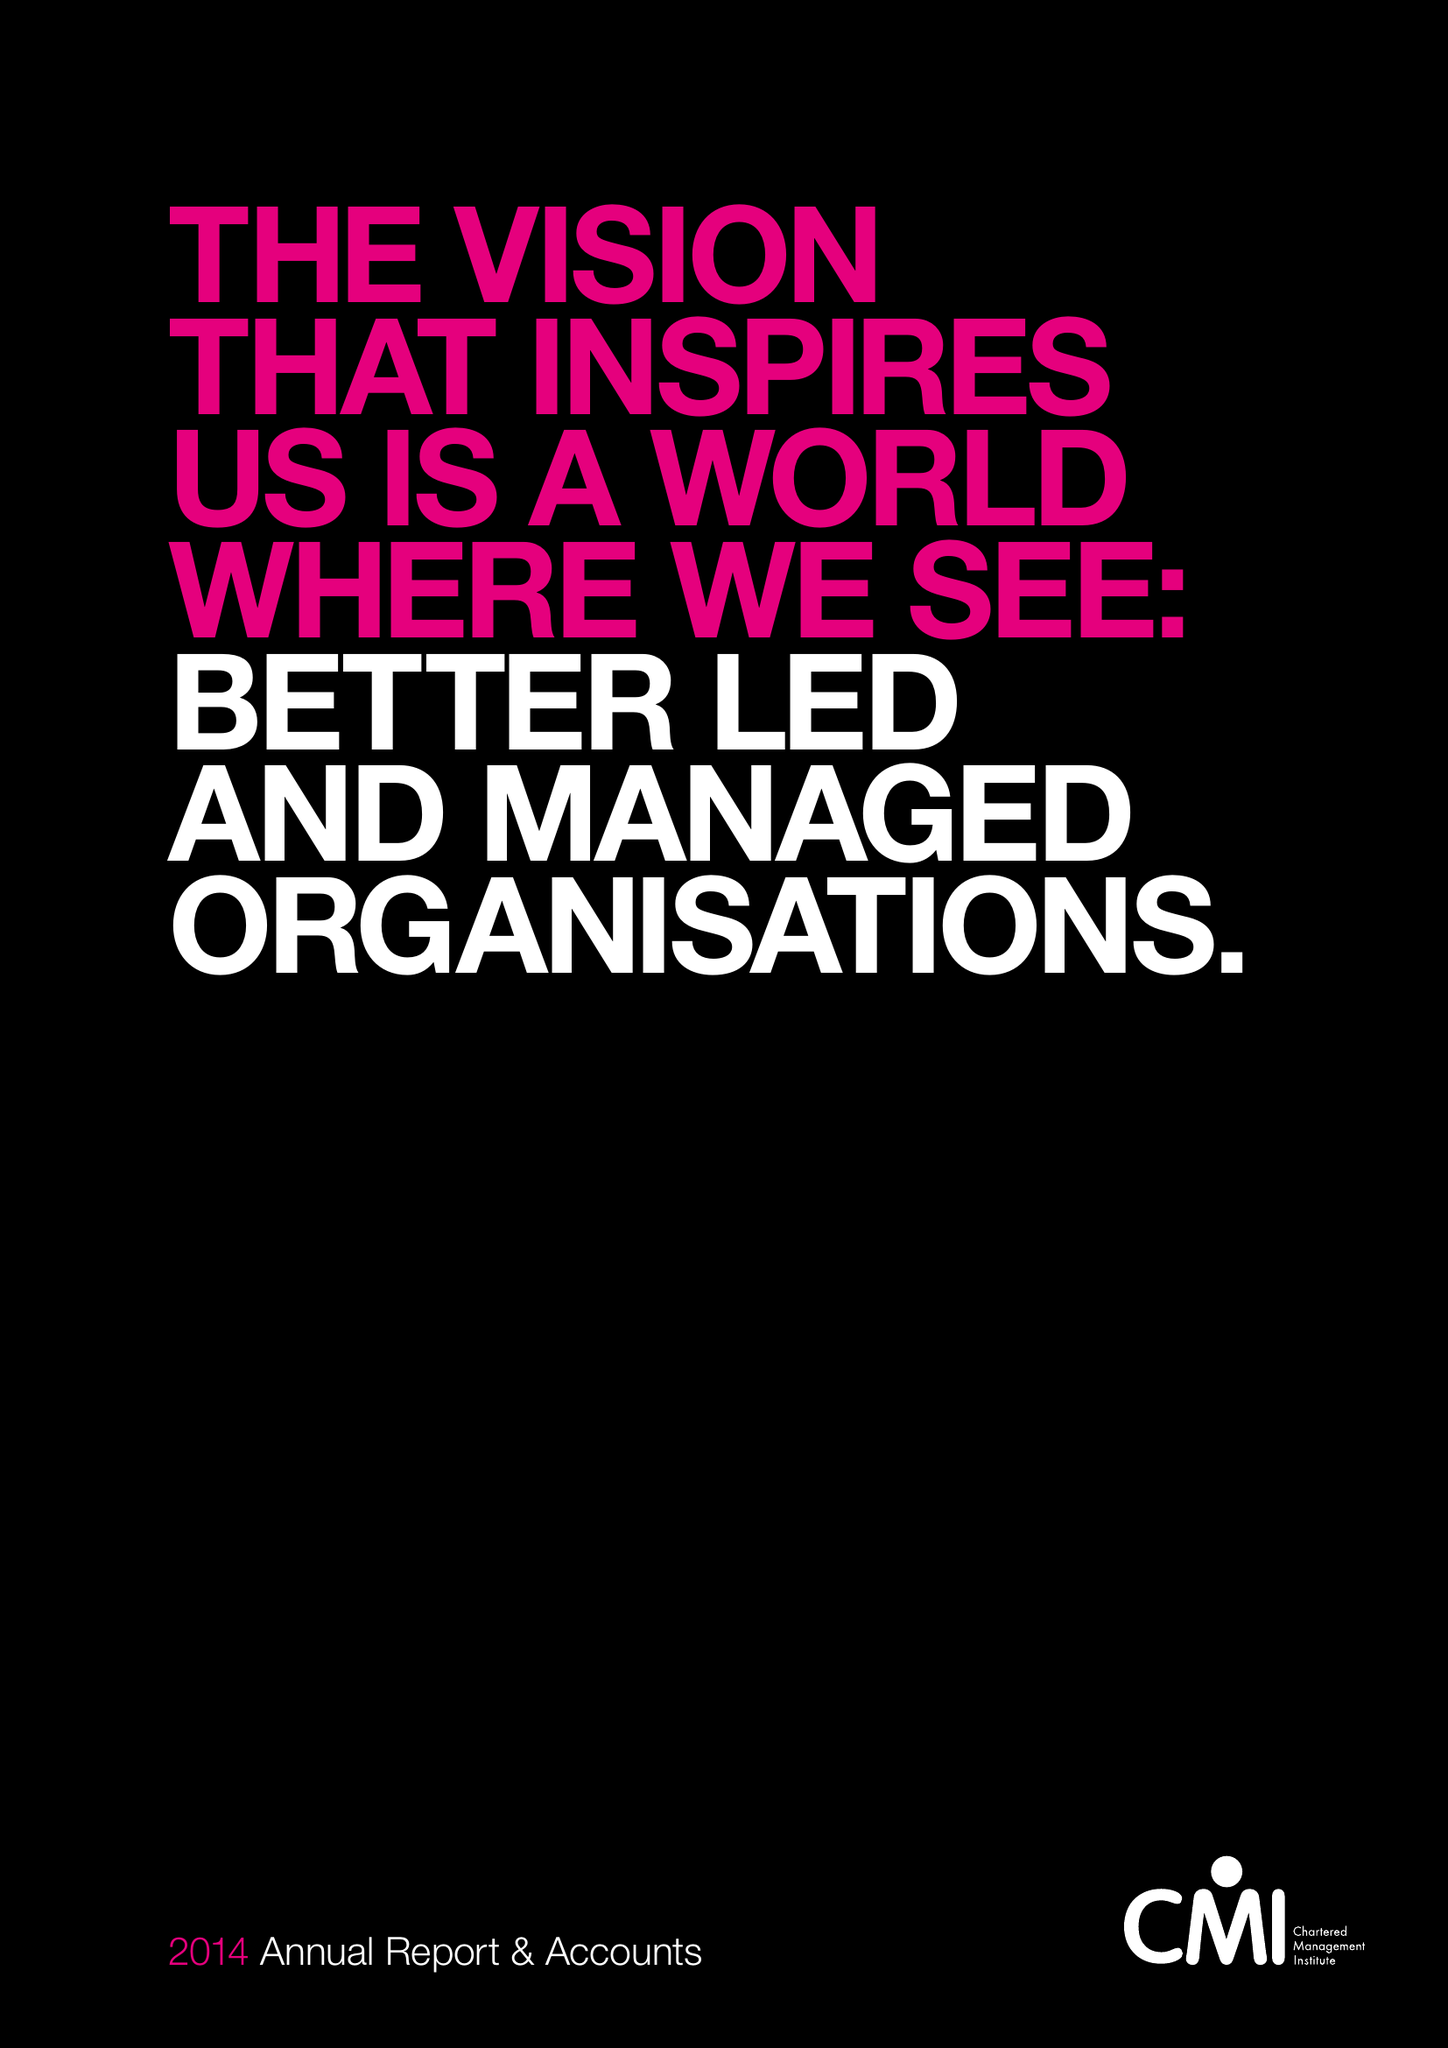What is the value for the charity_name?
Answer the question using a single word or phrase. Chartered Management Institute 